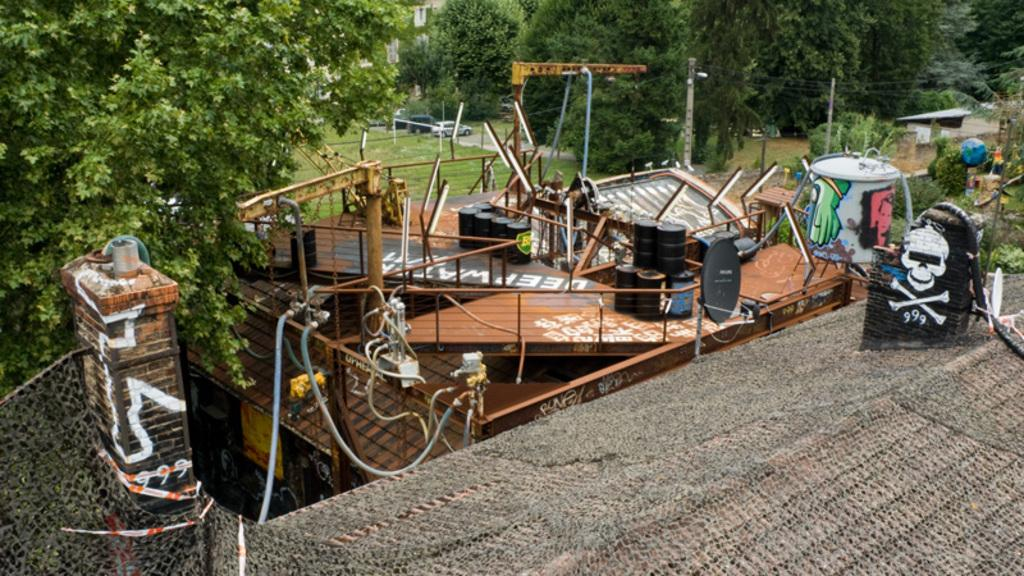What type of structure is visible in the image? There is a building in the image. What else can be seen in the image besides the building? There are drawings, trees, poles, wires, vehicles, and black color containers in the image. Can you describe the trees in the image? The trees are visible in the image. What are the poles used for in the image? The poles are likely used to support the wires in the image. What type of vehicles can be seen in the image? There are vehicles in the image, but their specific types are not mentioned. What type of coal is being offered by the kitty in the image? There is no kitty or coal present in the image. 